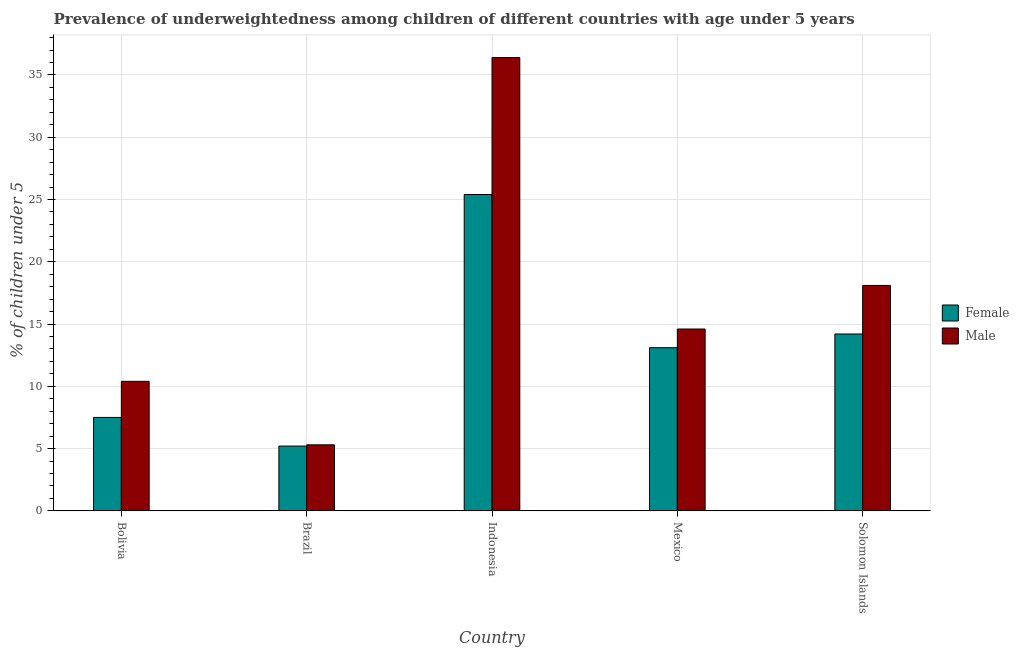How many different coloured bars are there?
Make the answer very short. 2. Are the number of bars per tick equal to the number of legend labels?
Offer a terse response. Yes. How many bars are there on the 1st tick from the right?
Offer a terse response. 2. What is the percentage of underweighted male children in Indonesia?
Keep it short and to the point. 36.4. Across all countries, what is the maximum percentage of underweighted male children?
Keep it short and to the point. 36.4. Across all countries, what is the minimum percentage of underweighted male children?
Give a very brief answer. 5.3. In which country was the percentage of underweighted male children minimum?
Provide a short and direct response. Brazil. What is the total percentage of underweighted female children in the graph?
Ensure brevity in your answer.  65.4. What is the difference between the percentage of underweighted female children in Brazil and that in Mexico?
Your answer should be compact. -7.9. What is the difference between the percentage of underweighted male children in Bolivia and the percentage of underweighted female children in Brazil?
Provide a short and direct response. 5.2. What is the average percentage of underweighted male children per country?
Provide a succinct answer. 16.96. What is the difference between the percentage of underweighted female children and percentage of underweighted male children in Brazil?
Ensure brevity in your answer.  -0.1. In how many countries, is the percentage of underweighted male children greater than 21 %?
Ensure brevity in your answer.  1. What is the ratio of the percentage of underweighted male children in Brazil to that in Solomon Islands?
Make the answer very short. 0.29. What is the difference between the highest and the second highest percentage of underweighted male children?
Provide a short and direct response. 18.3. What is the difference between the highest and the lowest percentage of underweighted female children?
Make the answer very short. 20.2. In how many countries, is the percentage of underweighted female children greater than the average percentage of underweighted female children taken over all countries?
Your response must be concise. 3. What does the 1st bar from the right in Indonesia represents?
Your response must be concise. Male. How many bars are there?
Your answer should be compact. 10. Are all the bars in the graph horizontal?
Give a very brief answer. No. Does the graph contain grids?
Make the answer very short. Yes. Where does the legend appear in the graph?
Your answer should be very brief. Center right. What is the title of the graph?
Your answer should be compact. Prevalence of underweightedness among children of different countries with age under 5 years. Does "Urban agglomerations" appear as one of the legend labels in the graph?
Make the answer very short. No. What is the label or title of the X-axis?
Offer a very short reply. Country. What is the label or title of the Y-axis?
Offer a terse response.  % of children under 5. What is the  % of children under 5 in Female in Bolivia?
Provide a short and direct response. 7.5. What is the  % of children under 5 in Male in Bolivia?
Your response must be concise. 10.4. What is the  % of children under 5 of Female in Brazil?
Offer a very short reply. 5.2. What is the  % of children under 5 in Male in Brazil?
Keep it short and to the point. 5.3. What is the  % of children under 5 in Female in Indonesia?
Your answer should be very brief. 25.4. What is the  % of children under 5 of Male in Indonesia?
Give a very brief answer. 36.4. What is the  % of children under 5 in Female in Mexico?
Ensure brevity in your answer.  13.1. What is the  % of children under 5 in Male in Mexico?
Your answer should be compact. 14.6. What is the  % of children under 5 of Female in Solomon Islands?
Your answer should be compact. 14.2. What is the  % of children under 5 in Male in Solomon Islands?
Offer a terse response. 18.1. Across all countries, what is the maximum  % of children under 5 of Female?
Provide a succinct answer. 25.4. Across all countries, what is the maximum  % of children under 5 in Male?
Offer a terse response. 36.4. Across all countries, what is the minimum  % of children under 5 in Female?
Give a very brief answer. 5.2. Across all countries, what is the minimum  % of children under 5 in Male?
Make the answer very short. 5.3. What is the total  % of children under 5 of Female in the graph?
Offer a very short reply. 65.4. What is the total  % of children under 5 of Male in the graph?
Make the answer very short. 84.8. What is the difference between the  % of children under 5 in Female in Bolivia and that in Indonesia?
Your answer should be compact. -17.9. What is the difference between the  % of children under 5 in Male in Bolivia and that in Indonesia?
Your answer should be very brief. -26. What is the difference between the  % of children under 5 of Female in Brazil and that in Indonesia?
Provide a short and direct response. -20.2. What is the difference between the  % of children under 5 of Male in Brazil and that in Indonesia?
Your answer should be compact. -31.1. What is the difference between the  % of children under 5 in Female in Brazil and that in Mexico?
Your answer should be compact. -7.9. What is the difference between the  % of children under 5 of Male in Brazil and that in Mexico?
Ensure brevity in your answer.  -9.3. What is the difference between the  % of children under 5 in Female in Brazil and that in Solomon Islands?
Your response must be concise. -9. What is the difference between the  % of children under 5 of Male in Brazil and that in Solomon Islands?
Your response must be concise. -12.8. What is the difference between the  % of children under 5 in Male in Indonesia and that in Mexico?
Your answer should be very brief. 21.8. What is the difference between the  % of children under 5 in Male in Indonesia and that in Solomon Islands?
Offer a very short reply. 18.3. What is the difference between the  % of children under 5 in Female in Bolivia and the  % of children under 5 in Male in Brazil?
Offer a very short reply. 2.2. What is the difference between the  % of children under 5 in Female in Bolivia and the  % of children under 5 in Male in Indonesia?
Your response must be concise. -28.9. What is the difference between the  % of children under 5 in Female in Brazil and the  % of children under 5 in Male in Indonesia?
Your answer should be compact. -31.2. What is the difference between the  % of children under 5 in Female in Indonesia and the  % of children under 5 in Male in Mexico?
Give a very brief answer. 10.8. What is the difference between the  % of children under 5 in Female in Indonesia and the  % of children under 5 in Male in Solomon Islands?
Your answer should be compact. 7.3. What is the average  % of children under 5 in Female per country?
Ensure brevity in your answer.  13.08. What is the average  % of children under 5 in Male per country?
Offer a very short reply. 16.96. What is the difference between the  % of children under 5 of Female and  % of children under 5 of Male in Solomon Islands?
Keep it short and to the point. -3.9. What is the ratio of the  % of children under 5 in Female in Bolivia to that in Brazil?
Ensure brevity in your answer.  1.44. What is the ratio of the  % of children under 5 of Male in Bolivia to that in Brazil?
Offer a very short reply. 1.96. What is the ratio of the  % of children under 5 in Female in Bolivia to that in Indonesia?
Give a very brief answer. 0.3. What is the ratio of the  % of children under 5 in Male in Bolivia to that in Indonesia?
Offer a terse response. 0.29. What is the ratio of the  % of children under 5 in Female in Bolivia to that in Mexico?
Give a very brief answer. 0.57. What is the ratio of the  % of children under 5 in Male in Bolivia to that in Mexico?
Give a very brief answer. 0.71. What is the ratio of the  % of children under 5 in Female in Bolivia to that in Solomon Islands?
Keep it short and to the point. 0.53. What is the ratio of the  % of children under 5 of Male in Bolivia to that in Solomon Islands?
Make the answer very short. 0.57. What is the ratio of the  % of children under 5 of Female in Brazil to that in Indonesia?
Make the answer very short. 0.2. What is the ratio of the  % of children under 5 in Male in Brazil to that in Indonesia?
Offer a terse response. 0.15. What is the ratio of the  % of children under 5 of Female in Brazil to that in Mexico?
Your answer should be compact. 0.4. What is the ratio of the  % of children under 5 in Male in Brazil to that in Mexico?
Offer a terse response. 0.36. What is the ratio of the  % of children under 5 of Female in Brazil to that in Solomon Islands?
Your response must be concise. 0.37. What is the ratio of the  % of children under 5 in Male in Brazil to that in Solomon Islands?
Offer a terse response. 0.29. What is the ratio of the  % of children under 5 in Female in Indonesia to that in Mexico?
Your answer should be compact. 1.94. What is the ratio of the  % of children under 5 in Male in Indonesia to that in Mexico?
Provide a succinct answer. 2.49. What is the ratio of the  % of children under 5 in Female in Indonesia to that in Solomon Islands?
Your response must be concise. 1.79. What is the ratio of the  % of children under 5 of Male in Indonesia to that in Solomon Islands?
Keep it short and to the point. 2.01. What is the ratio of the  % of children under 5 of Female in Mexico to that in Solomon Islands?
Your response must be concise. 0.92. What is the ratio of the  % of children under 5 of Male in Mexico to that in Solomon Islands?
Give a very brief answer. 0.81. What is the difference between the highest and the lowest  % of children under 5 in Female?
Make the answer very short. 20.2. What is the difference between the highest and the lowest  % of children under 5 in Male?
Your answer should be very brief. 31.1. 